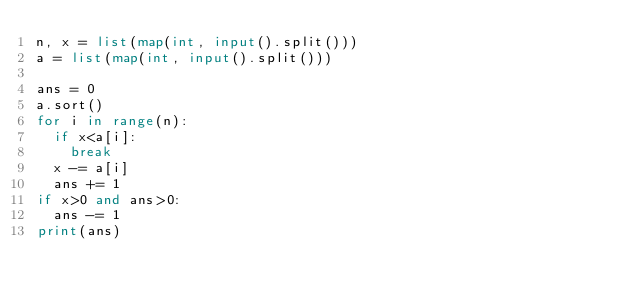Convert code to text. <code><loc_0><loc_0><loc_500><loc_500><_Python_>n, x = list(map(int, input().split()))
a = list(map(int, input().split()))

ans = 0
a.sort()
for i in range(n):
  if x<a[i]:
    break
  x -= a[i]
  ans += 1
if x>0 and ans>0:
  ans -= 1
print(ans)</code> 